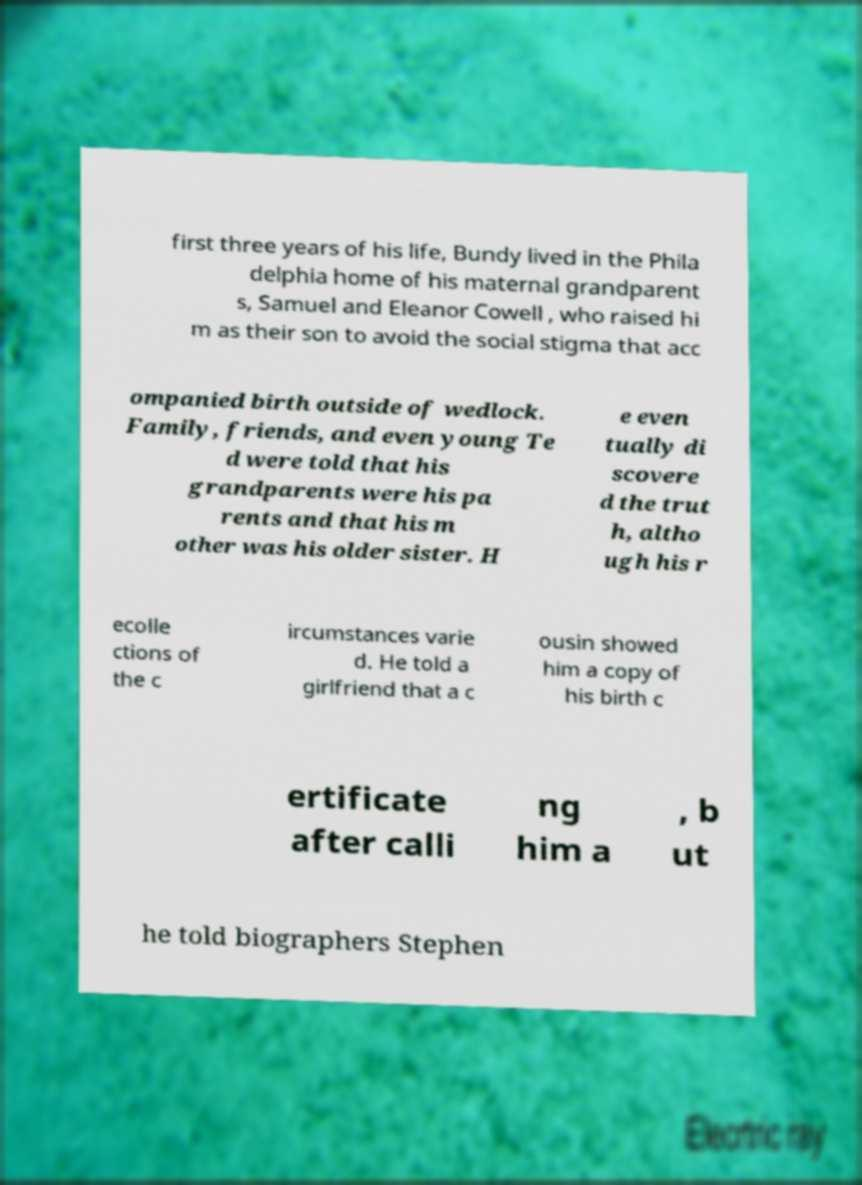Can you read and provide the text displayed in the image?This photo seems to have some interesting text. Can you extract and type it out for me? first three years of his life, Bundy lived in the Phila delphia home of his maternal grandparent s, Samuel and Eleanor Cowell , who raised hi m as their son to avoid the social stigma that acc ompanied birth outside of wedlock. Family, friends, and even young Te d were told that his grandparents were his pa rents and that his m other was his older sister. H e even tually di scovere d the trut h, altho ugh his r ecolle ctions of the c ircumstances varie d. He told a girlfriend that a c ousin showed him a copy of his birth c ertificate after calli ng him a , b ut he told biographers Stephen 